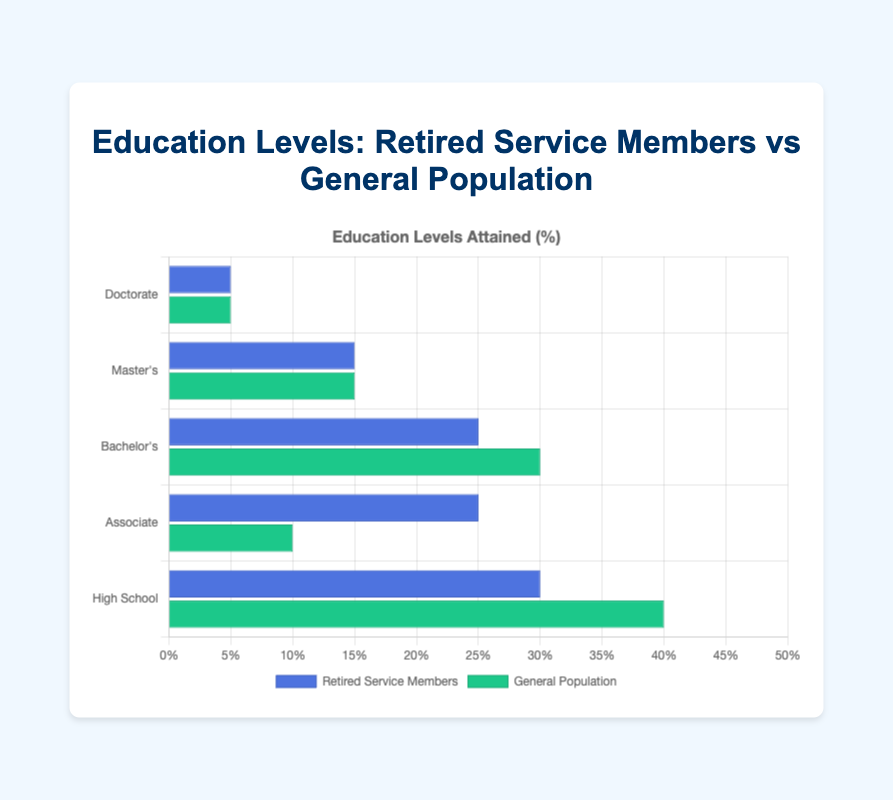What percentage of retired service members have attained an Associate degree? According to the figure, the bar representing Retired Service Members for the Associate degree is marked at 25%.
Answer: 25% How do the percentages of retired service members with a high school degree compare to the general population? The figure shows that 30% of retired service members have a high school degree, while 40% of the general population does.
Answer: 30% for Retired Service Members, 40% for General Population What is the difference in the percentage of Bachelor's degree attainment between retired service members and the general population? The figure shows Bachelor's degree attainment is 25% for Retired Service Members and 30% for the General Population. The difference is 30% - 25% = 5%.
Answer: 5% Which group has a higher percentage of individuals with a Master's degree, retired service members or the general population? According to the figure, both retired service members and the general population have 15% of their members with a Master's degree.
Answer: Both are equal What percentage of the General Population have a Doctorate degree? The figure shows the bar representing the General Population for the Doctorate degree is marked at 5%.
Answer: 5% What is the combined percentage of retired service members with either an Associate or Bachelor's degree? The Associate degree is 25% and the Bachelor's degree is also 25%. The combined percentage is 25% + 25% = 50%.
Answer: 50% How does the percentage of high school degree attainment in the general population compare to the percentage of Bachelor's degree attainment in the same group? The figure shows 40% for high school and 30% for Bachelor's in the general population. Therefore, the high school attainment is higher.
Answer: High school is higher Which degree type has the lowest percentage for both groups? From the figure, both groups have the lowest percentage of individuals with a Doctorate degree, which stands at 5%.
Answer: Doctorate In which degree types do retired service members have a higher percentage than the general population? Retired service members have higher percentages in Associate (25% vs 10%) and are equal in Master's (15%) and Doctorate (5%) degrees.
Answer: Associate What is the total percentage of the General Population with at least a Bachelor's degree? The general population has 30% with a Bachelor's degree, 15% with a Master's degree, and 5% with a Doctorate. Therefore, the total percentage is 30% + 15% + 5% = 50%.
Answer: 50% 